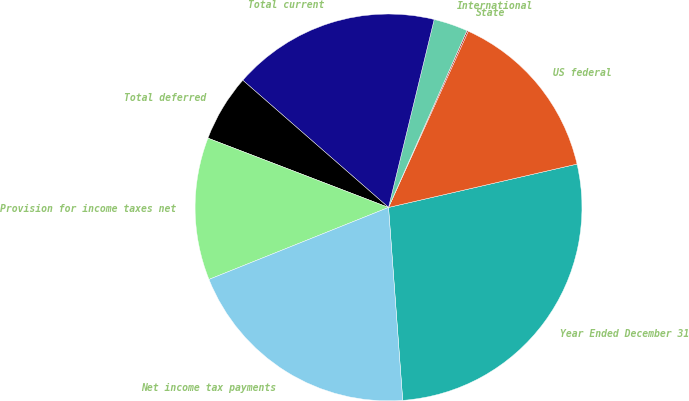Convert chart to OTSL. <chart><loc_0><loc_0><loc_500><loc_500><pie_chart><fcel>Year Ended December 31<fcel>US federal<fcel>State<fcel>International<fcel>Total current<fcel>Total deferred<fcel>Provision for income taxes net<fcel>Net income tax payments<nl><fcel>27.43%<fcel>14.64%<fcel>0.12%<fcel>2.85%<fcel>17.37%<fcel>5.59%<fcel>11.9%<fcel>20.1%<nl></chart> 